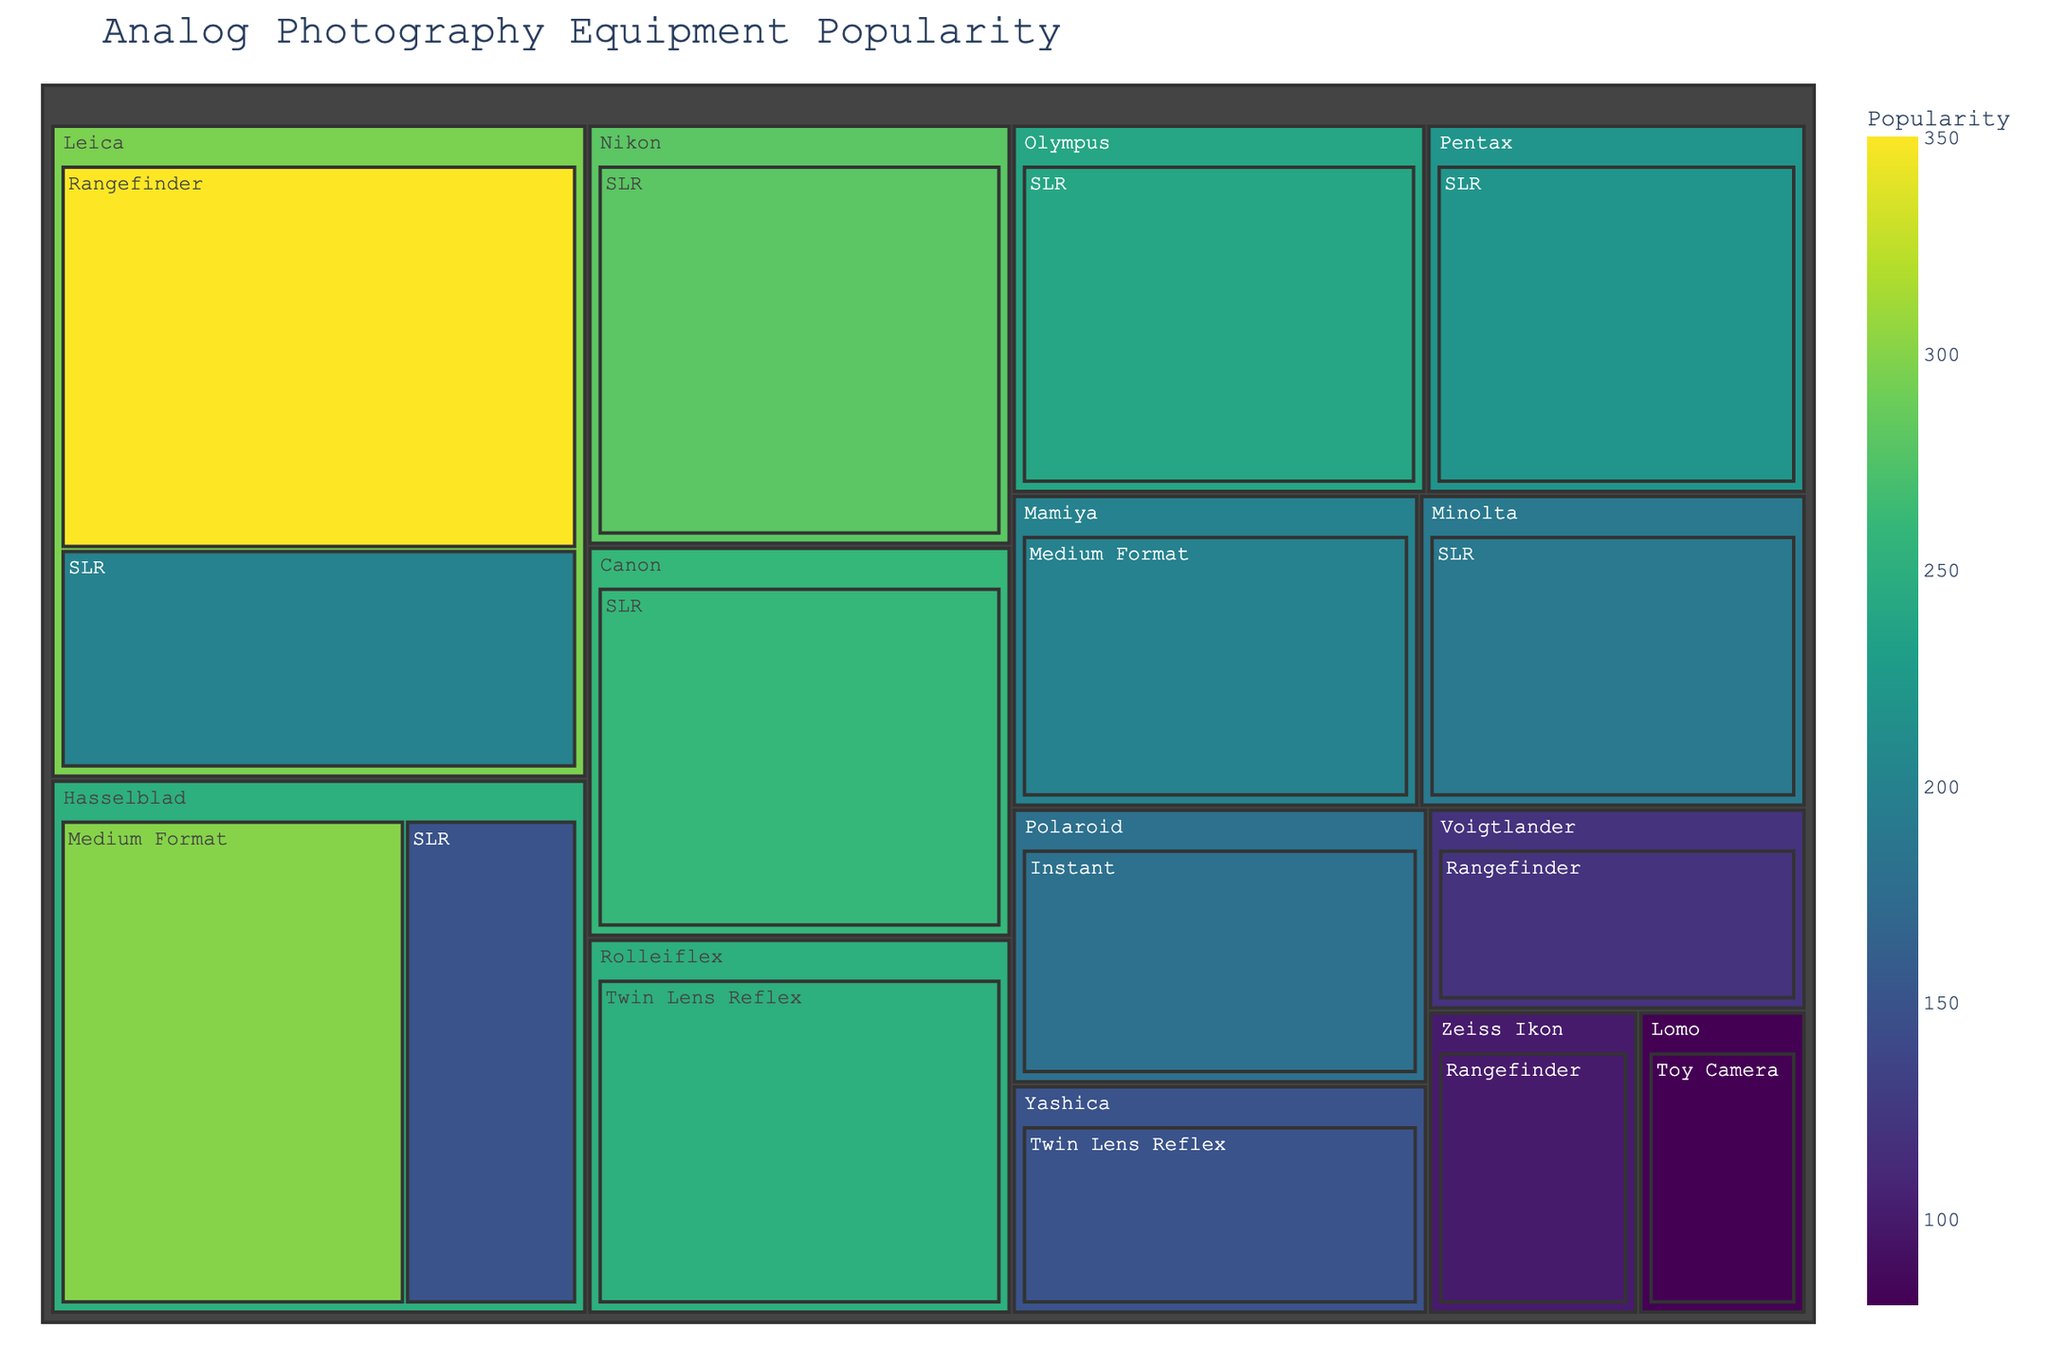What is the title of the treemap? The title of the treemap is displayed prominently at the top of the figure. By observing this, we can identify the title.
Answer: Analog Photography Equipment Popularity Which brand has the highest popularity for SLR cameras? By looking at the SLR camera types and comparing the sizes of the boxes corresponding to different brands, we identify the largest box.
Answer: Nikon What is the combined popularity of Leica's Rangefinder and SLR cameras? By adding the popularity values given for Leica's Rangefinder (350) and SLR (200) cameras, we get the combined popularity. 350 + 200 = 550
Answer: 550 How does the popularity of Hasselblad's Medium Format cameras compare to its SLR cameras? The values for Hasselblad's Medium Format and SLR cameras are 300 and 150 respectively. By comparing these values, we see that Medium Format is more popular.
Answer: Hasselblad's Medium Format is more popular Which brand has the least popular camera type presented in the treemap? By observing the smallest box in the treemap, we identify Lomo as the brand, and its camera type as Toy Camera.
Answer: Lomo, Toy Camera How many brands are represented in the treemap? Count each unique brand listed in the treemap. We can see that there are 11 brands in total.
Answer: 11 What is the difference in popularity between Nikon's SLR and Canon's SLR cameras? To find the difference, subtract Canon's SLR popularity (260) from Nikon's SLR popularity (280). 280 - 260 = 20
Answer: 20 Which camera type has the highest overall popularity by summing up all brands' values? Sum up the popularity values for each camera type and compare the totals. SLR: 200 + 150 + 220 + 280 + 260 + 240 + 190 = 1540; Medium Format: 300 + 200 = 500; Rangefinder: 350 + 120 + 100 = 570; Twin Lens Reflex: 250 + 150 = 400; Instant: 180; Toy Camera: 80. SLR has the highest total.
Answer: SLR What is the range of popularity values for Rangefinder cameras across different brands? Identify the minimum and maximum popularity values for Rangefinder cameras. The minimum is 100 (Zeiss Ikon), and the maximum is 350 (Leica). The range is 350 - 100 = 250.
Answer: 250 